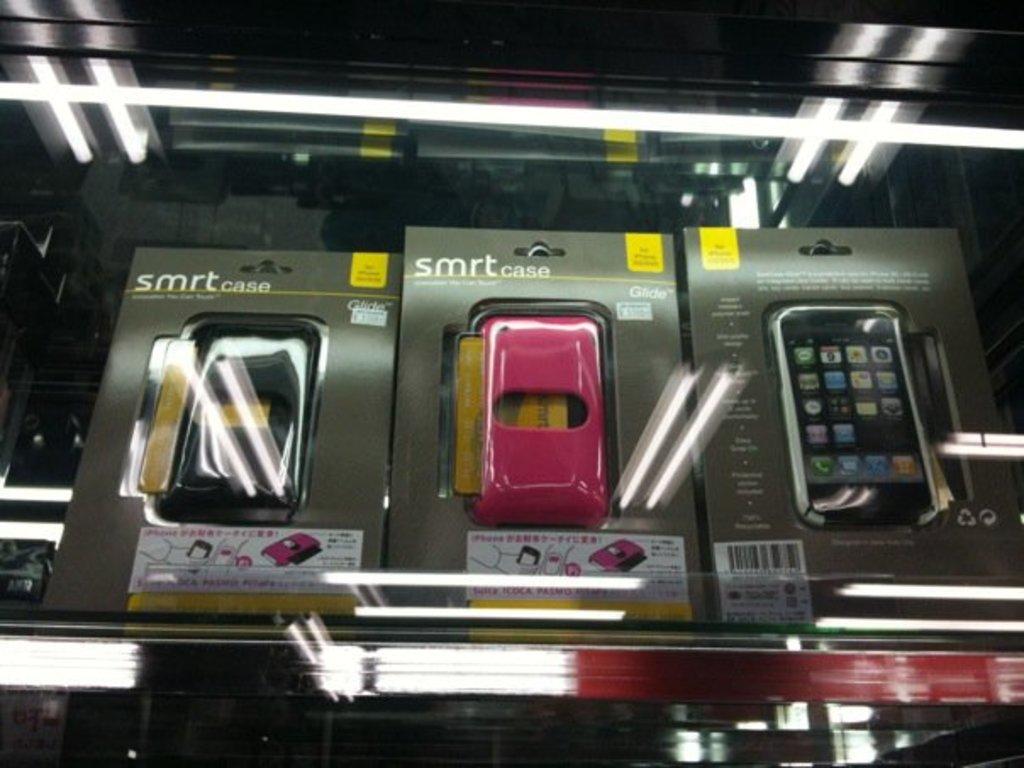Who makes the care?
Offer a terse response. Smrt. What is the model name of this case?
Your answer should be compact. Smrt. 